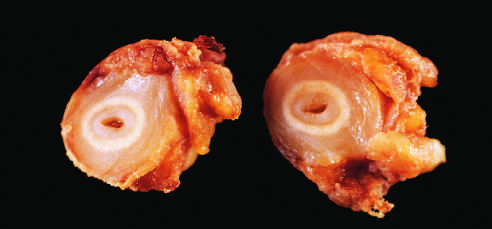do the cross-sections of the right carotid artery from the patient shown in the figure demonstrate marked intimal thickening and luminal narrowing?
Answer the question using a single word or phrase. Yes 